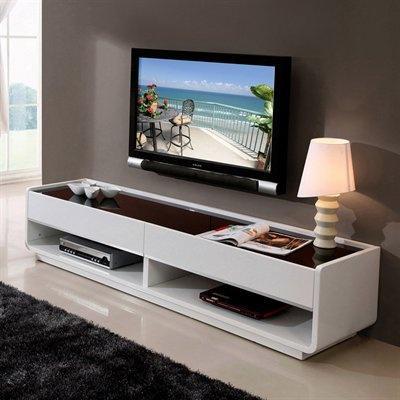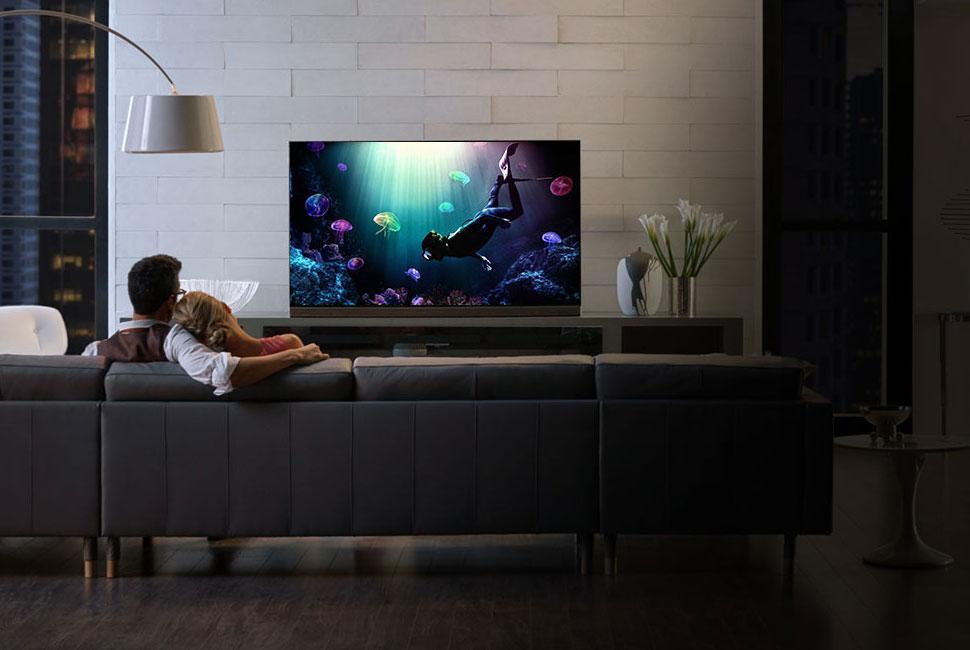The first image is the image on the left, the second image is the image on the right. Evaluate the accuracy of this statement regarding the images: "Someone is watching TV white sitting on a couch in the right image.". Is it true? Answer yes or no. Yes. The first image is the image on the left, the second image is the image on the right. For the images shown, is this caption "There is only one tv in each image" true? Answer yes or no. Yes. 